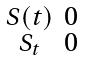<formula> <loc_0><loc_0><loc_500><loc_500>\begin{smallmatrix} S ( t ) & 0 \\ S _ { t } & 0 \end{smallmatrix}</formula> 